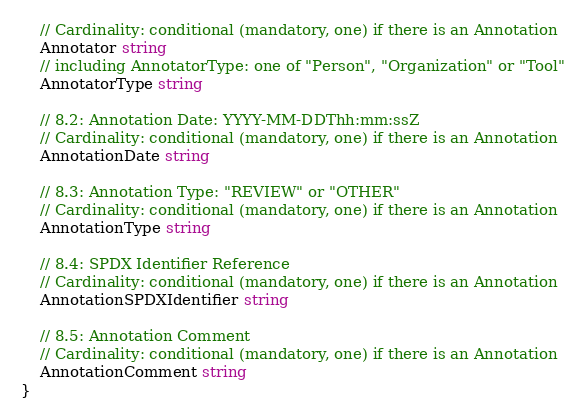Convert code to text. <code><loc_0><loc_0><loc_500><loc_500><_Go_>	// Cardinality: conditional (mandatory, one) if there is an Annotation
	Annotator string
	// including AnnotatorType: one of "Person", "Organization" or "Tool"
	AnnotatorType string

	// 8.2: Annotation Date: YYYY-MM-DDThh:mm:ssZ
	// Cardinality: conditional (mandatory, one) if there is an Annotation
	AnnotationDate string

	// 8.3: Annotation Type: "REVIEW" or "OTHER"
	// Cardinality: conditional (mandatory, one) if there is an Annotation
	AnnotationType string

	// 8.4: SPDX Identifier Reference
	// Cardinality: conditional (mandatory, one) if there is an Annotation
	AnnotationSPDXIdentifier string

	// 8.5: Annotation Comment
	// Cardinality: conditional (mandatory, one) if there is an Annotation
	AnnotationComment string
}
</code> 